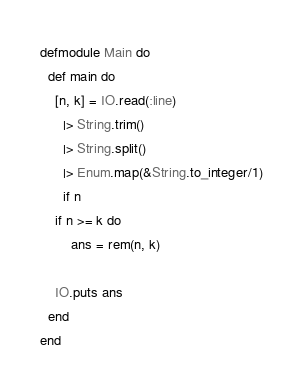<code> <loc_0><loc_0><loc_500><loc_500><_Elixir_>defmodule Main do
  def main do
	[n, k] = IO.read(:line)
      |> String.trim()
      |> String.split()
      |> Enum.map(&String.to_integer/1)
      if n
	if n >= k do
    	ans = rem(n, k)
    
	IO.puts ans
  end
end
</code> 